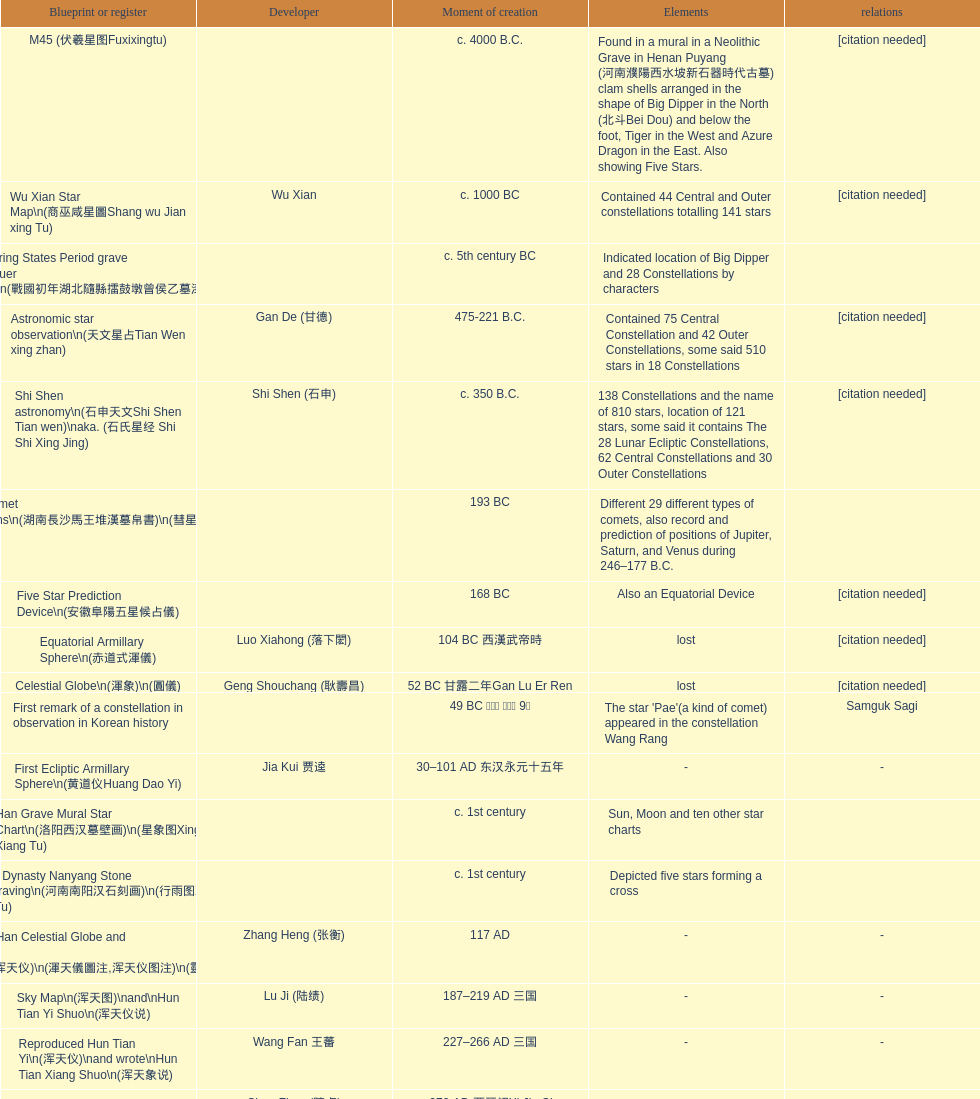Which was the first chinese star map known to have been created? M45 (伏羲星图Fuxixingtu). 